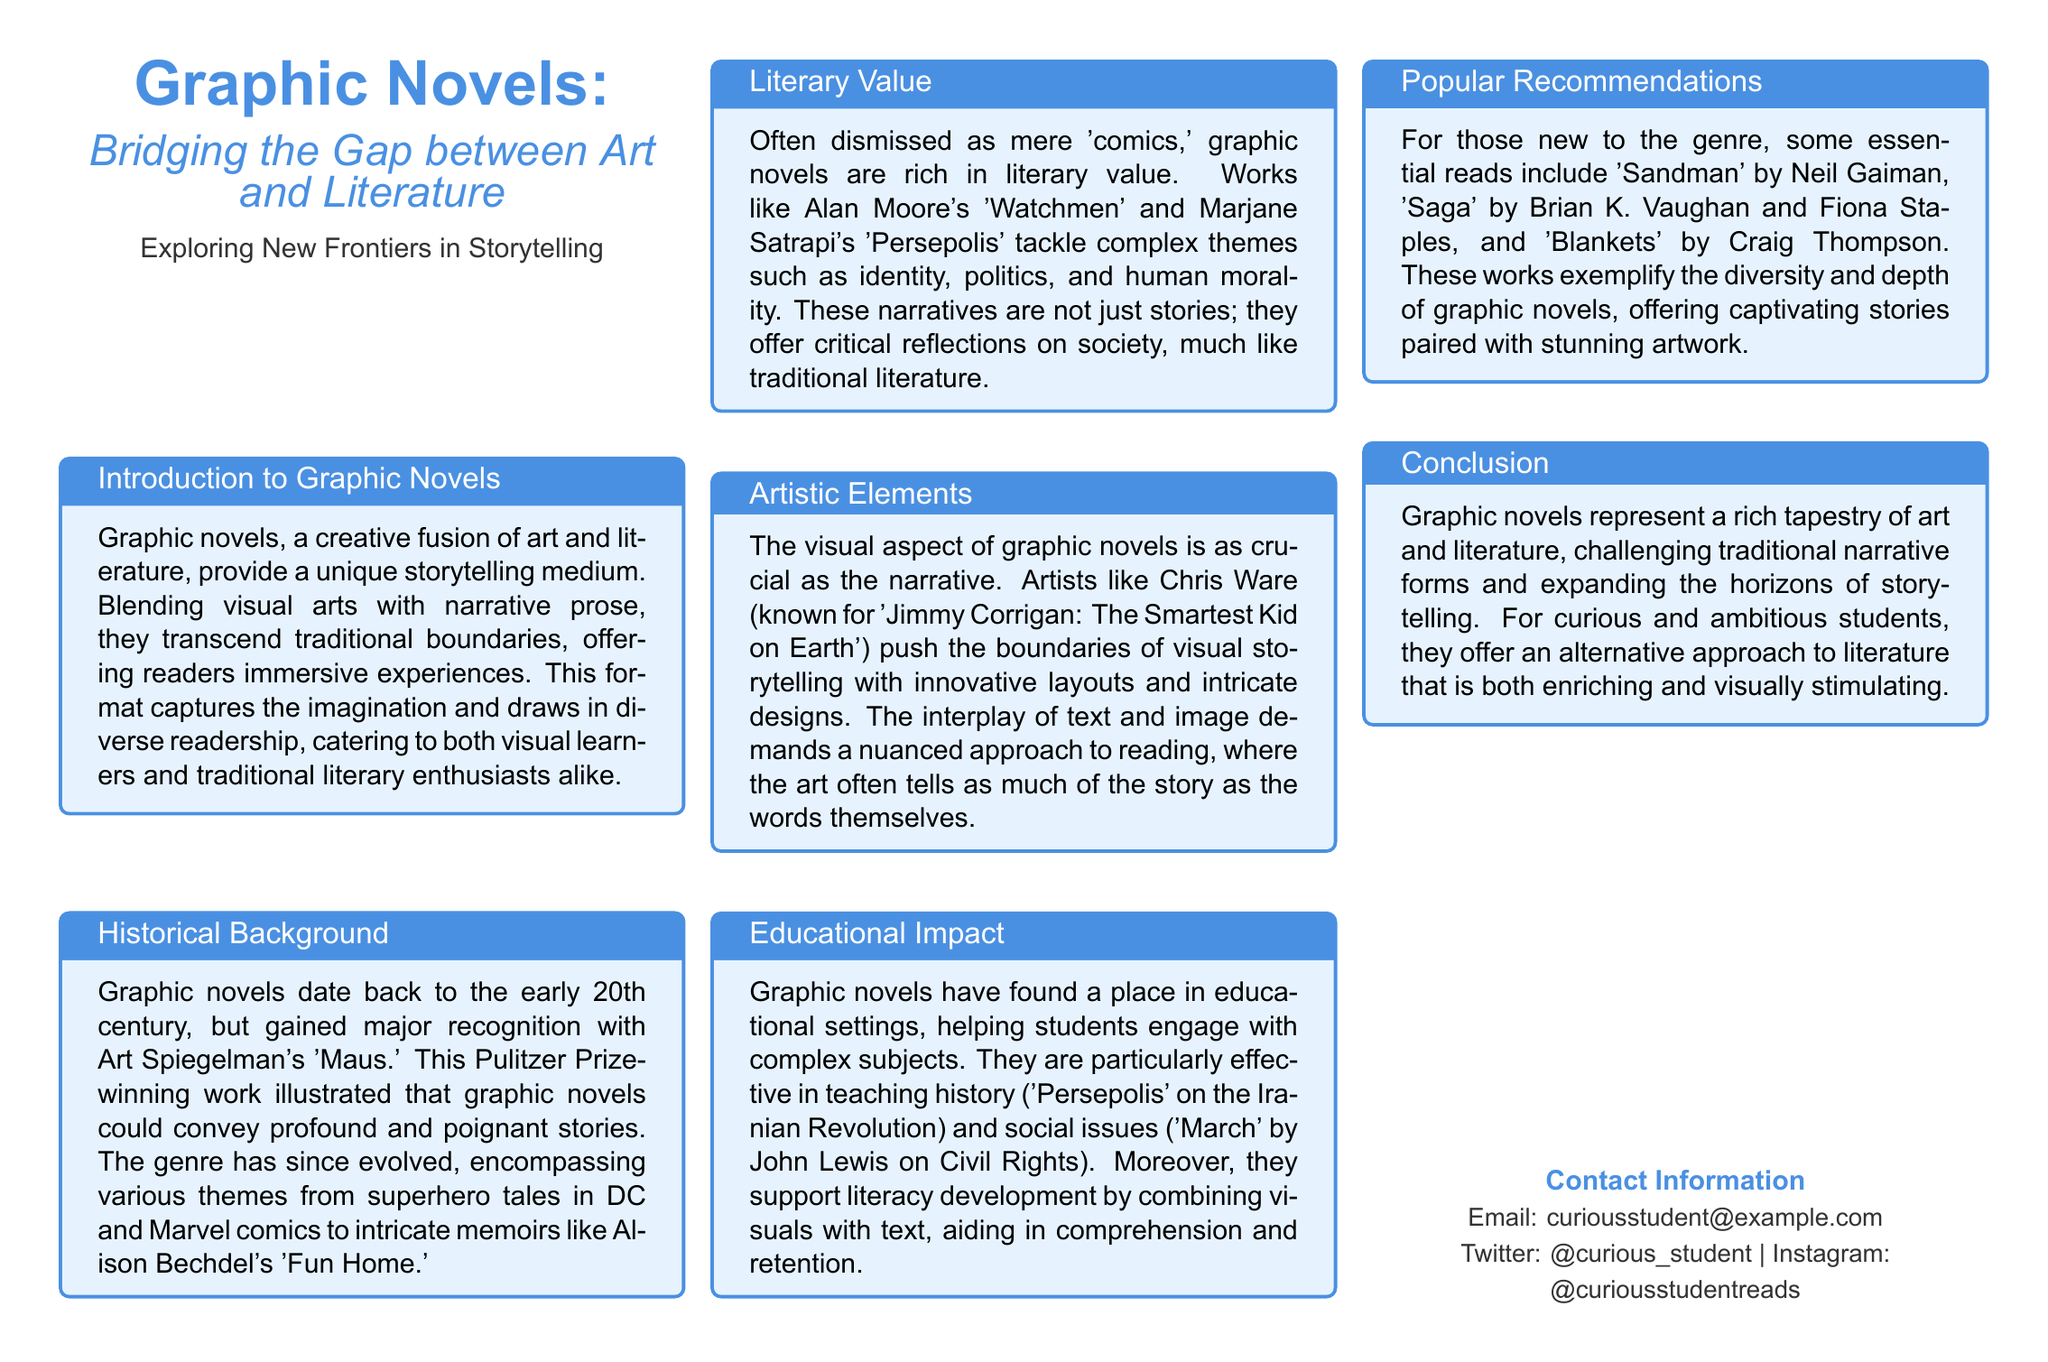What Pulitzer Prize-winning work is mentioned? The document refers to Art Spiegelman's 'Maus' as the Pulitzer Prize-winning work that exemplified graphic novels' capacity to convey profound stories.
Answer: Maus Which graphic novel tackles the Iranian Revolution? The document notes that 'Persepolis' addresses the Iranian Revolution, highlighting its use in educational settings and as a teaching tool.
Answer: Persepolis Who is the author of 'Sandman'? The document provides the name of the author of 'Sandman', which is Neil Gaiman.
Answer: Neil Gaiman What are the two essential elements that graphic novels blend? The text describes that graphic novels creatively fuse art and literature, effectively merging these two elements.
Answer: Art and literature What is one of the popular recommendations for newcomers to graphic novels? The document lists 'Saga' as one of the recommended graphic novels for those new to the genre.
Answer: Saga What impact do graphic novels have according to the document? The document explains that graphic novels have a significant educational impact by helping students engage with complex subjects.
Answer: Educational impact What does the document suggest graphic novels challenge? The document indicates that graphic novels challenge traditional narrative forms, expanding storytelling horizons.
Answer: Traditional narrative forms What is emphasized as crucial in graphic novels besides the narrative? The document emphasizes that the visual aspect is as crucial as the narrative in graphic novels, highlighting the art's importance.
Answer: Visual aspect 